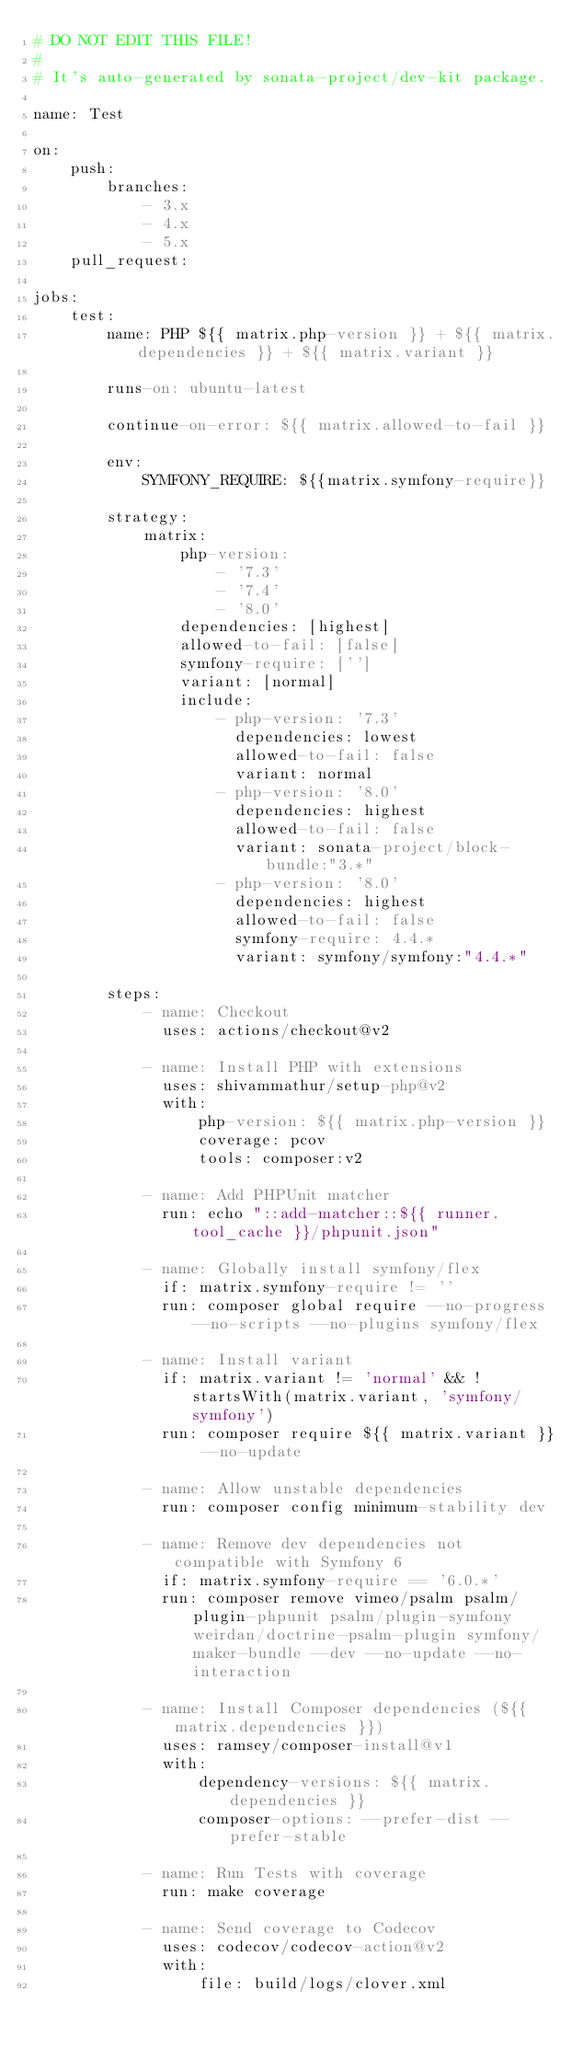Convert code to text. <code><loc_0><loc_0><loc_500><loc_500><_YAML_># DO NOT EDIT THIS FILE!
#
# It's auto-generated by sonata-project/dev-kit package.

name: Test

on:
    push:
        branches:
            - 3.x
            - 4.x
            - 5.x
    pull_request:

jobs:
    test:
        name: PHP ${{ matrix.php-version }} + ${{ matrix.dependencies }} + ${{ matrix.variant }}

        runs-on: ubuntu-latest

        continue-on-error: ${{ matrix.allowed-to-fail }}

        env:
            SYMFONY_REQUIRE: ${{matrix.symfony-require}}

        strategy:
            matrix:
                php-version:
                    - '7.3'
                    - '7.4'
                    - '8.0'
                dependencies: [highest]
                allowed-to-fail: [false]
                symfony-require: ['']
                variant: [normal]
                include:
                    - php-version: '7.3'
                      dependencies: lowest
                      allowed-to-fail: false
                      variant: normal
                    - php-version: '8.0'
                      dependencies: highest
                      allowed-to-fail: false
                      variant: sonata-project/block-bundle:"3.*"
                    - php-version: '8.0'
                      dependencies: highest
                      allowed-to-fail: false
                      symfony-require: 4.4.*
                      variant: symfony/symfony:"4.4.*"

        steps:
            - name: Checkout
              uses: actions/checkout@v2

            - name: Install PHP with extensions
              uses: shivammathur/setup-php@v2
              with:
                  php-version: ${{ matrix.php-version }}
                  coverage: pcov
                  tools: composer:v2

            - name: Add PHPUnit matcher
              run: echo "::add-matcher::${{ runner.tool_cache }}/phpunit.json"

            - name: Globally install symfony/flex
              if: matrix.symfony-require != ''
              run: composer global require --no-progress --no-scripts --no-plugins symfony/flex

            - name: Install variant
              if: matrix.variant != 'normal' && !startsWith(matrix.variant, 'symfony/symfony')
              run: composer require ${{ matrix.variant }} --no-update

            - name: Allow unstable dependencies
              run: composer config minimum-stability dev

            - name: Remove dev dependencies not compatible with Symfony 6
              if: matrix.symfony-require == '6.0.*'
              run: composer remove vimeo/psalm psalm/plugin-phpunit psalm/plugin-symfony weirdan/doctrine-psalm-plugin symfony/maker-bundle --dev --no-update --no-interaction

            - name: Install Composer dependencies (${{ matrix.dependencies }})
              uses: ramsey/composer-install@v1
              with:
                  dependency-versions: ${{ matrix.dependencies }}
                  composer-options: --prefer-dist --prefer-stable

            - name: Run Tests with coverage
              run: make coverage

            - name: Send coverage to Codecov
              uses: codecov/codecov-action@v2
              with:
                  file: build/logs/clover.xml
</code> 